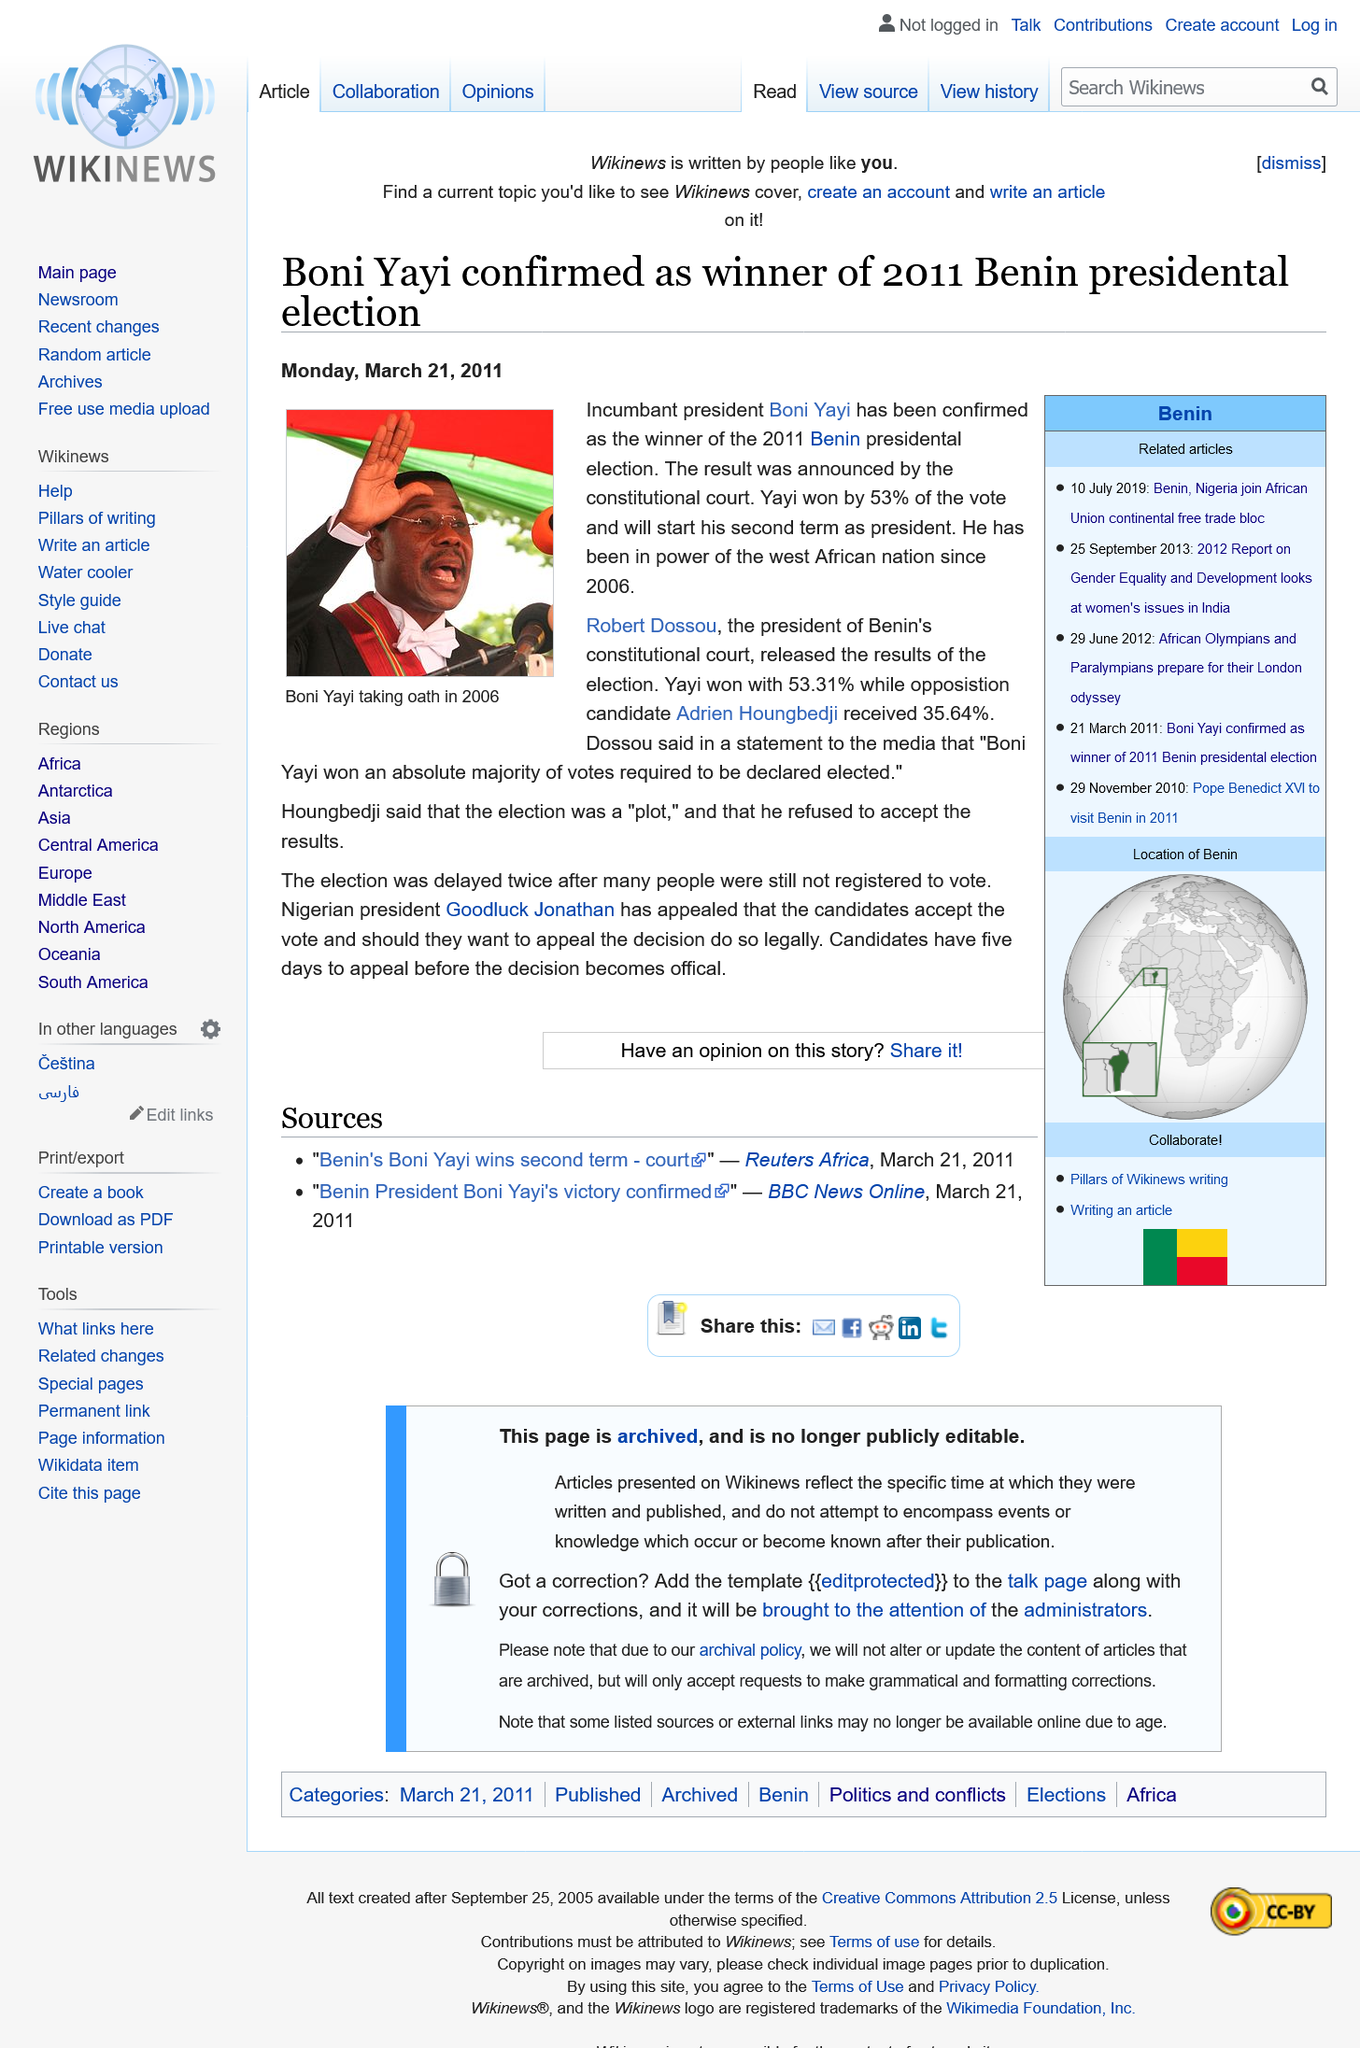Mention a couple of crucial points in this snapshot. Boni Yayi will begin his second term as the president. Adrien Houngbedji was the opposition candidate in the election. 